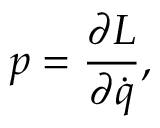<formula> <loc_0><loc_0><loc_500><loc_500>p = { \frac { \partial L } { \partial { \dot { q } } } } ,</formula> 